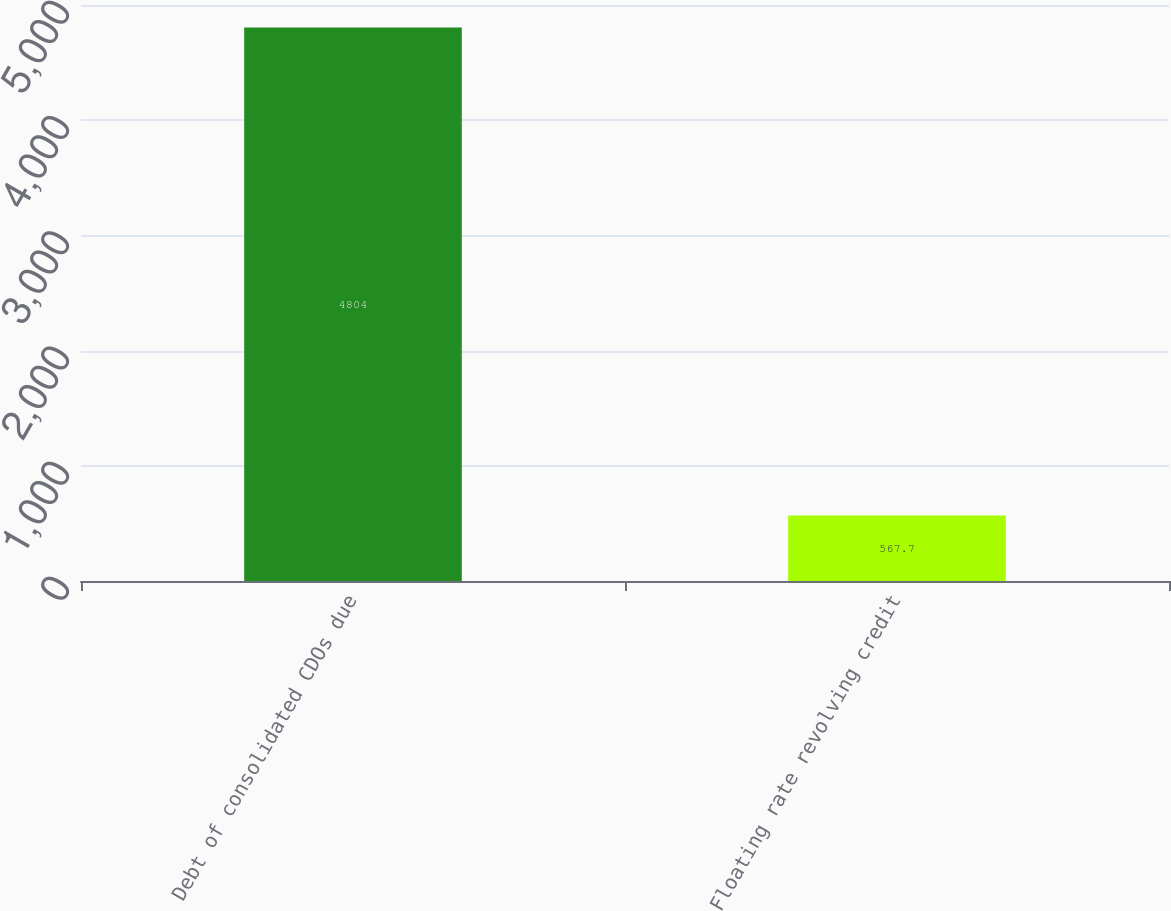Convert chart. <chart><loc_0><loc_0><loc_500><loc_500><bar_chart><fcel>Debt of consolidated CDOs due<fcel>Floating rate revolving credit<nl><fcel>4804<fcel>567.7<nl></chart> 